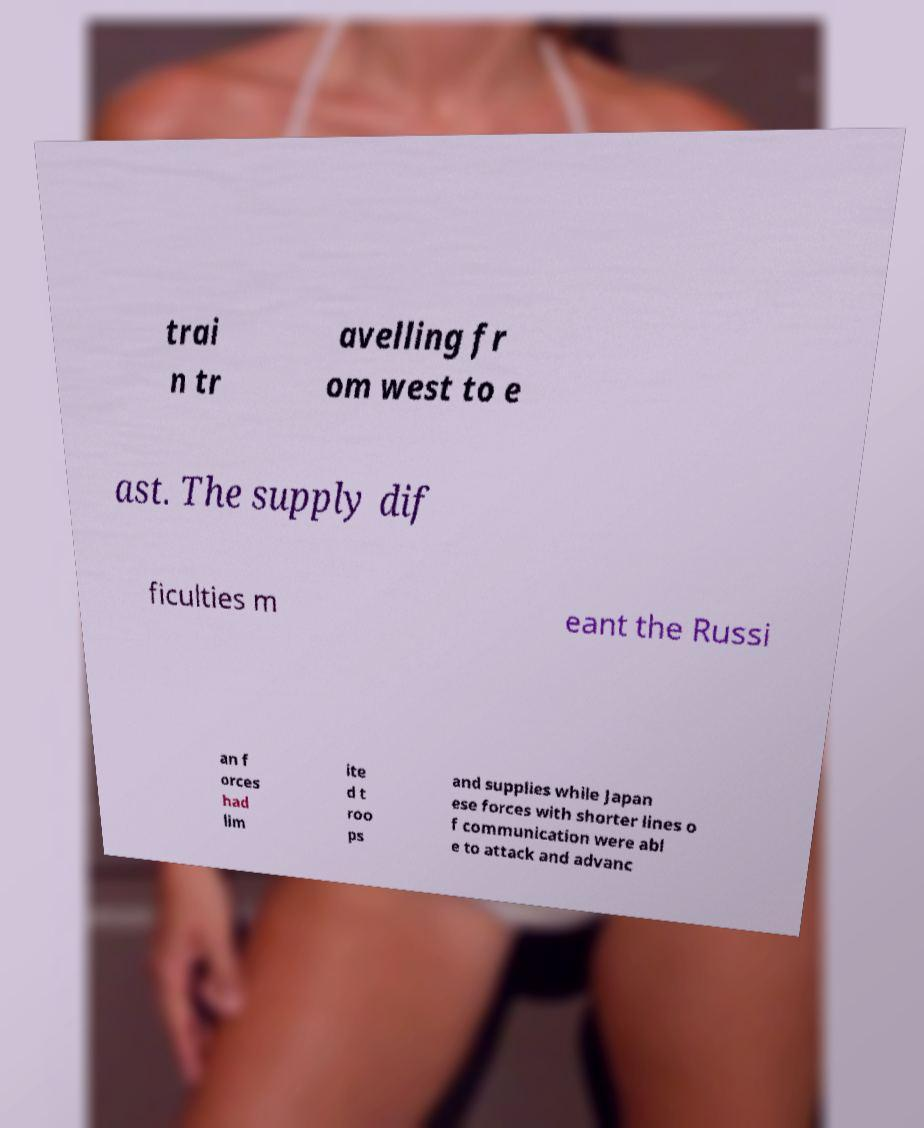I need the written content from this picture converted into text. Can you do that? trai n tr avelling fr om west to e ast. The supply dif ficulties m eant the Russi an f orces had lim ite d t roo ps and supplies while Japan ese forces with shorter lines o f communication were abl e to attack and advanc 